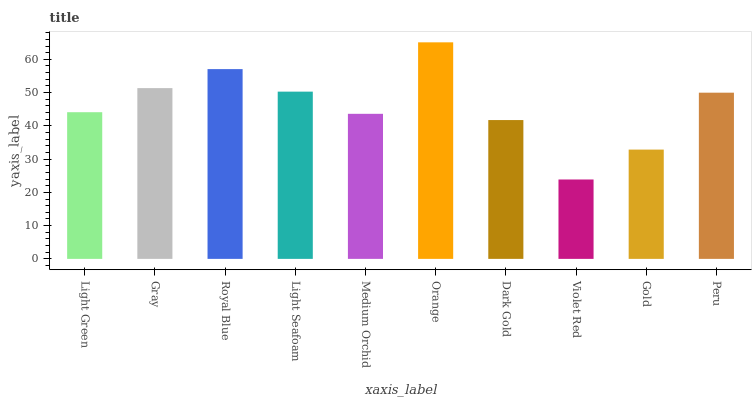Is Violet Red the minimum?
Answer yes or no. Yes. Is Orange the maximum?
Answer yes or no. Yes. Is Gray the minimum?
Answer yes or no. No. Is Gray the maximum?
Answer yes or no. No. Is Gray greater than Light Green?
Answer yes or no. Yes. Is Light Green less than Gray?
Answer yes or no. Yes. Is Light Green greater than Gray?
Answer yes or no. No. Is Gray less than Light Green?
Answer yes or no. No. Is Peru the high median?
Answer yes or no. Yes. Is Light Green the low median?
Answer yes or no. Yes. Is Light Seafoam the high median?
Answer yes or no. No. Is Light Seafoam the low median?
Answer yes or no. No. 